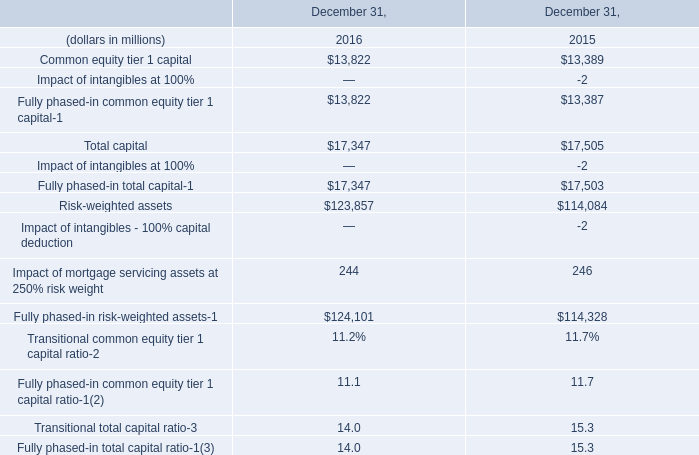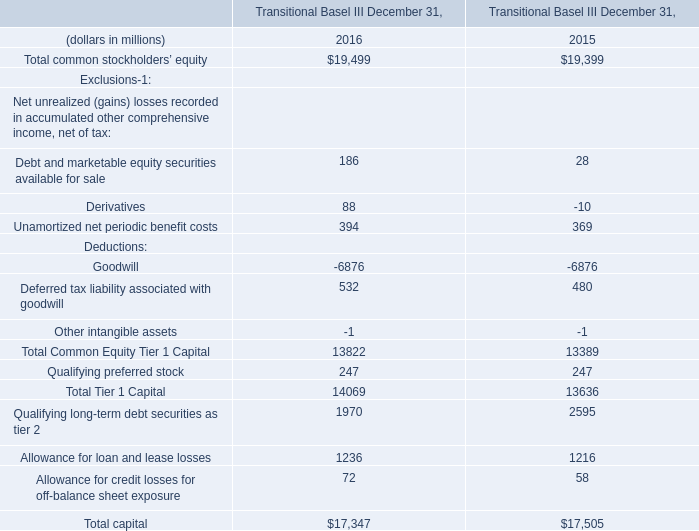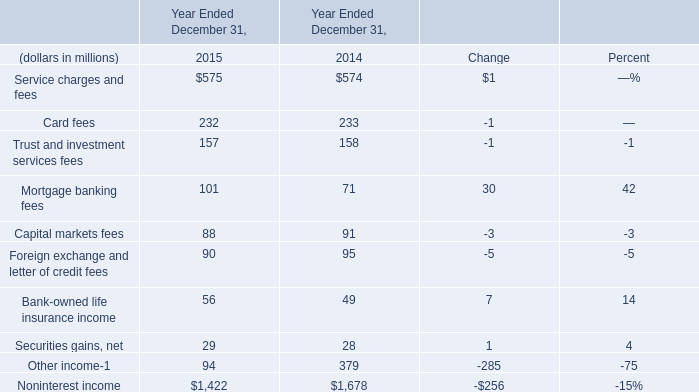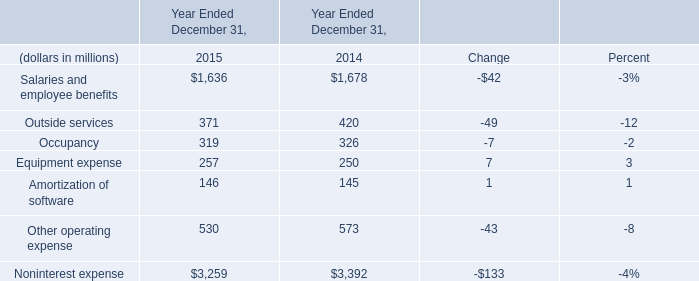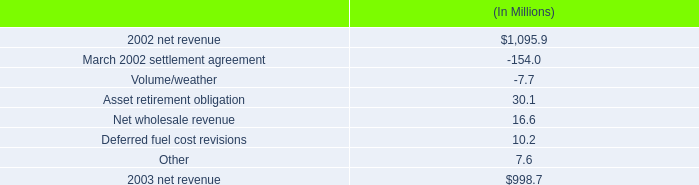What is the total value of outside services, occupancy, equipment expense and amortization of software in in 2015 ? 
Computations: (((371 + 319) + 257) + 146)
Answer: 1093.0. 